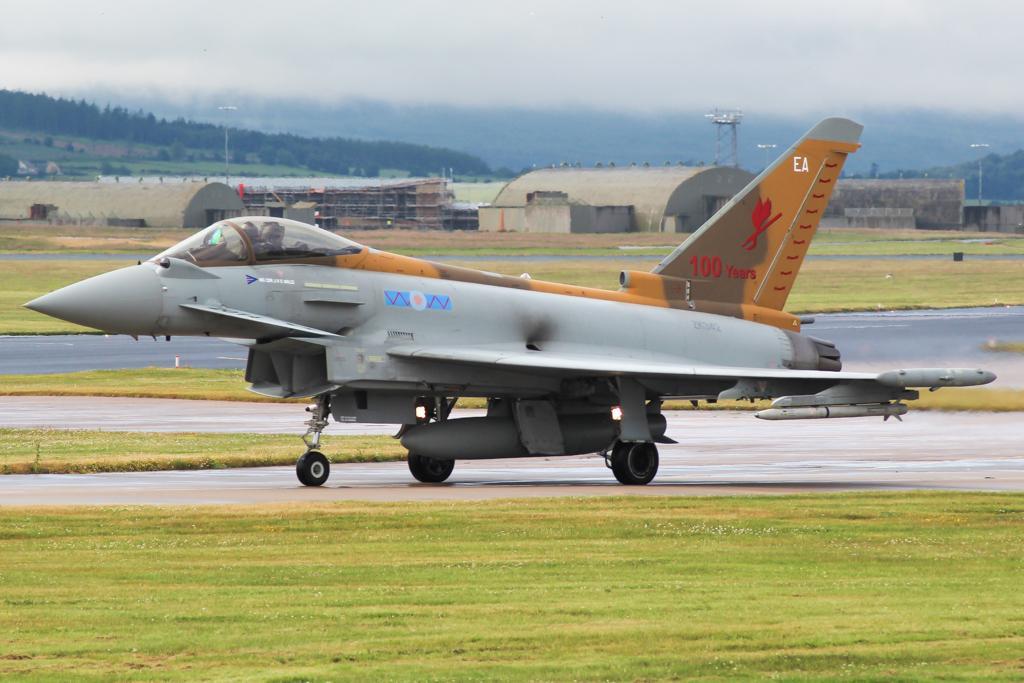Please provide a concise description of this image. In this picture we can see an aeroplane on the road. Here we can see grass, sheds, poles, tower, and trees. In the background there is sky. 